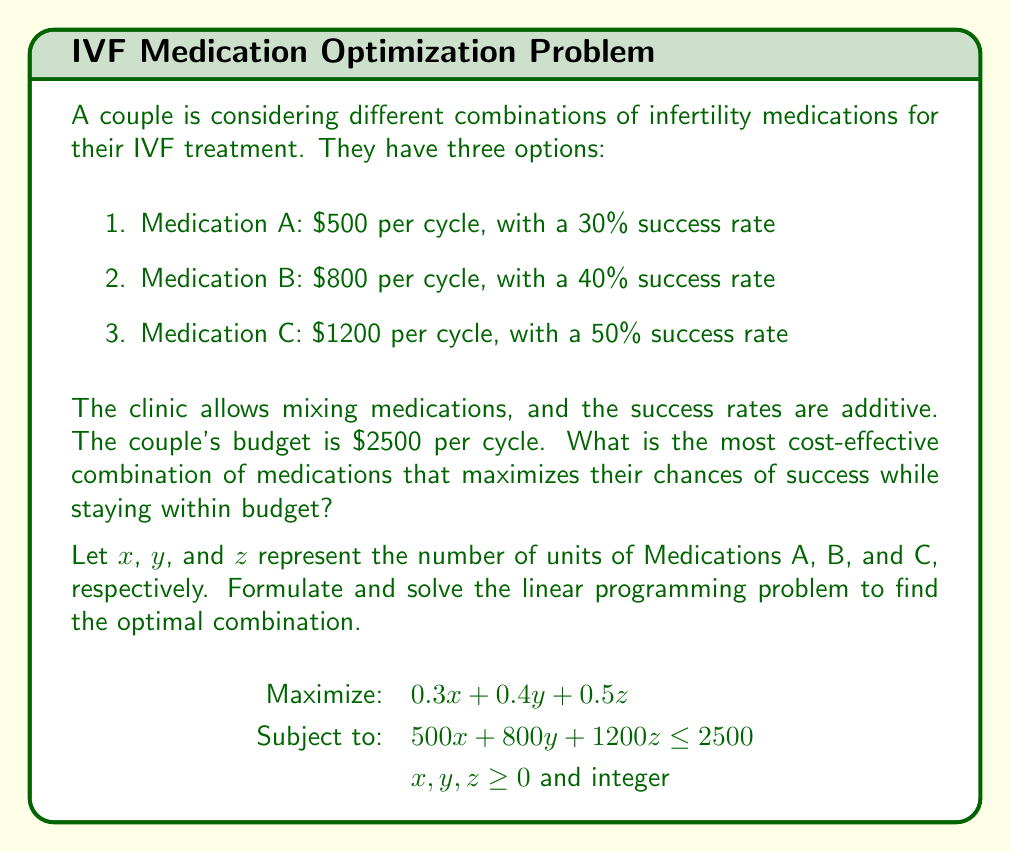What is the answer to this math problem? To solve this linear programming problem with integer constraints, we'll use the following steps:

1. Relax the integer constraint and solve the continuous LP problem.
2. Round down the solution to get a feasible integer solution.
3. Check nearby integer points for optimality.

Step 1: Solving the continuous LP problem

We can use the simplex method or graphical method. In this case, we'll use the graphical method due to the small number of variables.

First, we'll convert the inequality constraint to an equation:
$$ 500x + 800y + 1200z = 2500 $$

Now, we'll consider the extreme points of this plane within the first octant (x, y, z ≥ 0):

- (5, 0, 0): Success rate = 1.5
- (0, 3.125, 0): Success rate = 1.25
- (0, 0, 2.083): Success rate = 1.0415

The optimal continuous solution is (5, 0, 0), with a success rate of 1.5.

Step 2: Rounding down

The rounded-down solution is (5, 0, 0), which is already an integer solution.

Step 3: Checking nearby integer points

We'll check the points (4, 1, 0) and (3, 1, 1):

- (4, 1, 0): Cost = 2300, Success rate = 1.6
- (3, 1, 1): Cost = 2500, Success rate = 1.8

The optimal integer solution is (3, 1, 1), which uses 3 units of Medication A, 1 unit of Medication B, and 1 unit of Medication C.

This combination gives a success rate of 1.8 (or 180%) while staying within the budget of $2500.
Answer: 3 units of Medication A, 1 unit of Medication B, 1 unit of Medication C 